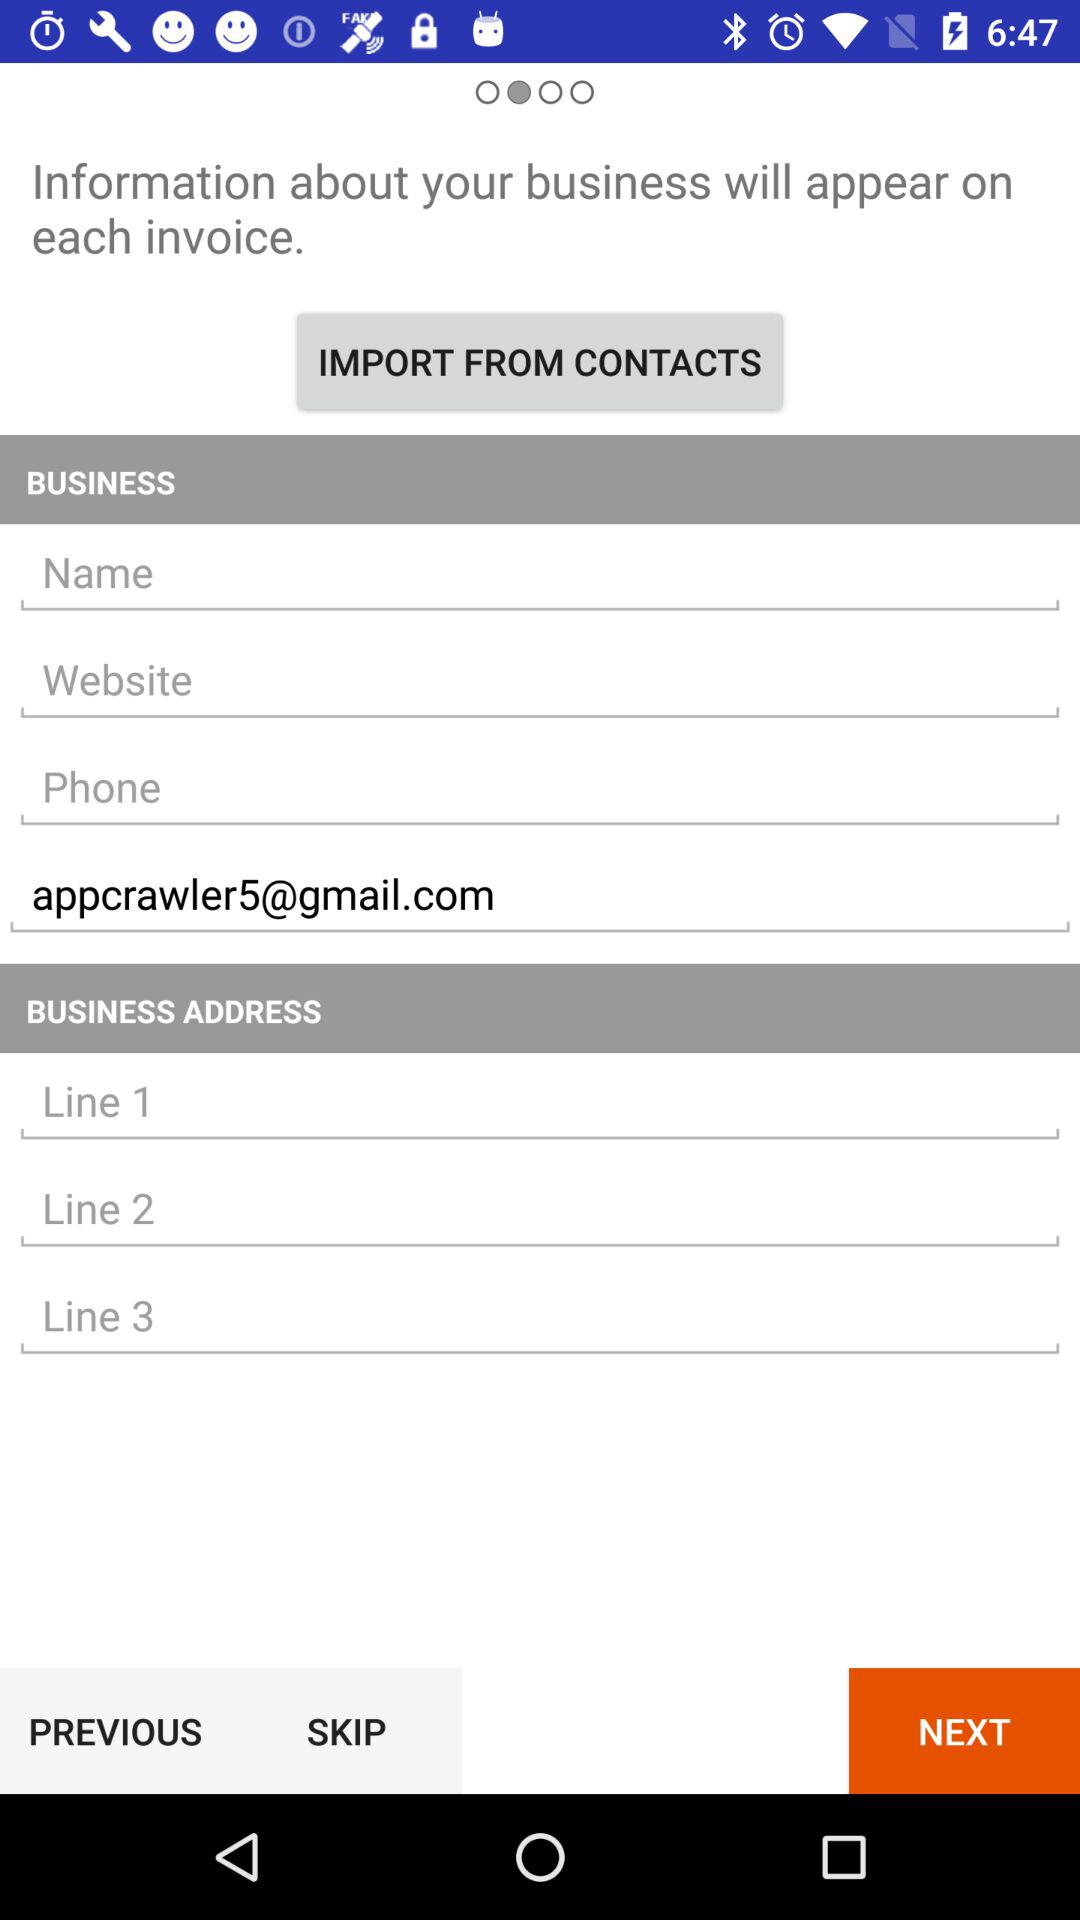How many lines of text does the business address section have?
Answer the question using a single word or phrase. 3 